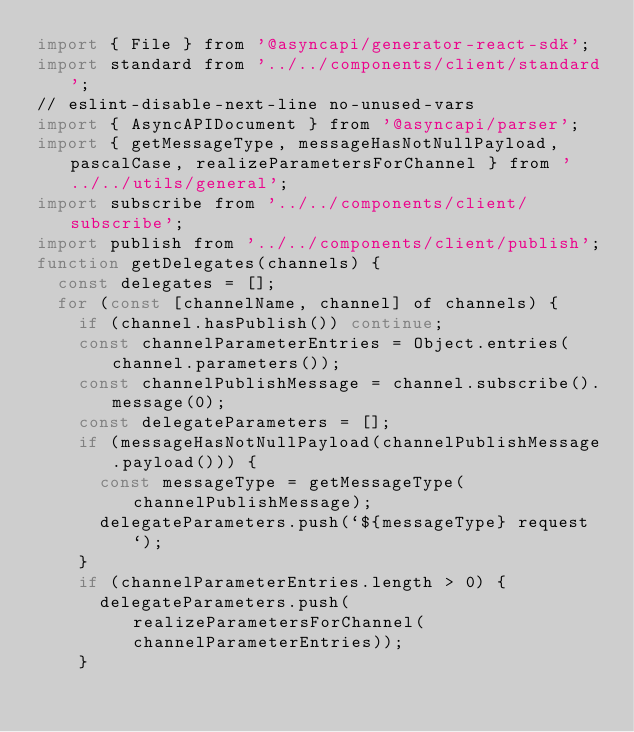<code> <loc_0><loc_0><loc_500><loc_500><_JavaScript_>import { File } from '@asyncapi/generator-react-sdk';
import standard from '../../components/client/standard';
// eslint-disable-next-line no-unused-vars
import { AsyncAPIDocument } from '@asyncapi/parser';
import { getMessageType, messageHasNotNullPayload, pascalCase, realizeParametersForChannel } from '../../utils/general';
import subscribe from '../../components/client/subscribe';
import publish from '../../components/client/publish';
function getDelegates(channels) {
  const delegates = [];
  for (const [channelName, channel] of channels) {
    if (channel.hasPublish()) continue;
    const channelParameterEntries = Object.entries(channel.parameters());
    const channelPublishMessage = channel.subscribe().message(0);
    const delegateParameters = [];
    if (messageHasNotNullPayload(channelPublishMessage.payload())) {
      const messageType = getMessageType(channelPublishMessage);
      delegateParameters.push(`${messageType} request`);
    }
    if (channelParameterEntries.length > 0) {
      delegateParameters.push(realizeParametersForChannel(channelParameterEntries));
    }</code> 